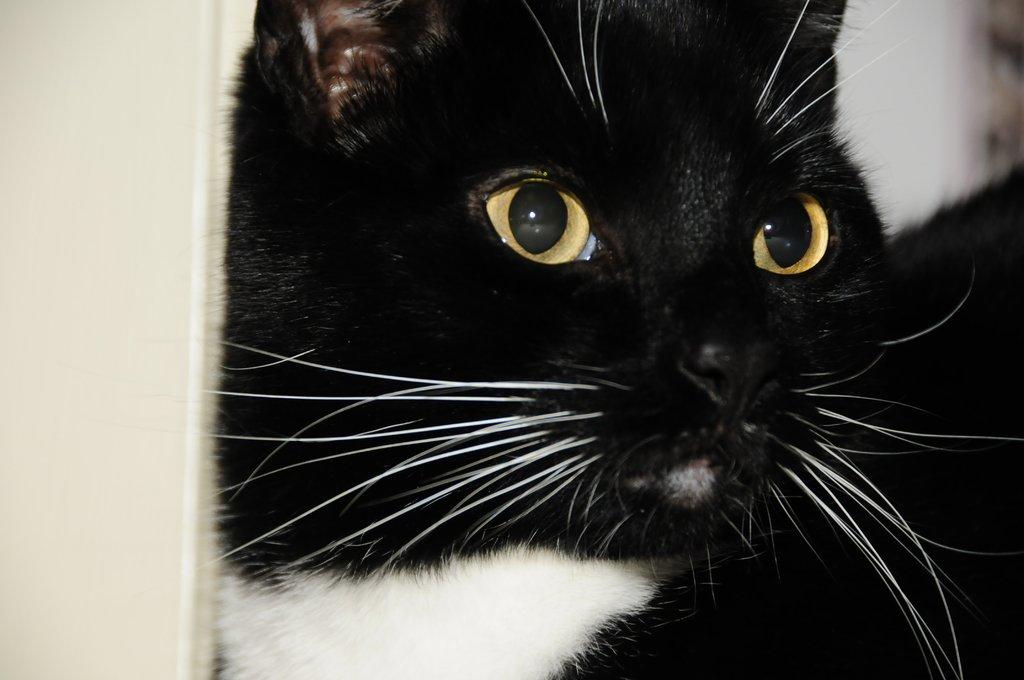What type of animal is in the image? There is a black cat in the image. What type of oatmeal is the cat eating in the image? There is no oatmeal present in the image; it only features a black cat. 